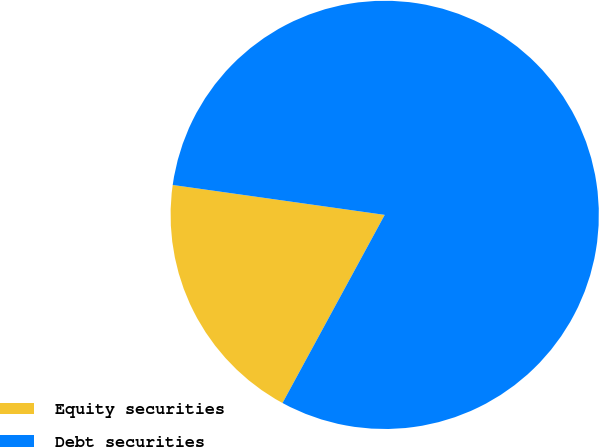<chart> <loc_0><loc_0><loc_500><loc_500><pie_chart><fcel>Equity securities<fcel>Debt securities<nl><fcel>19.31%<fcel>80.69%<nl></chart> 